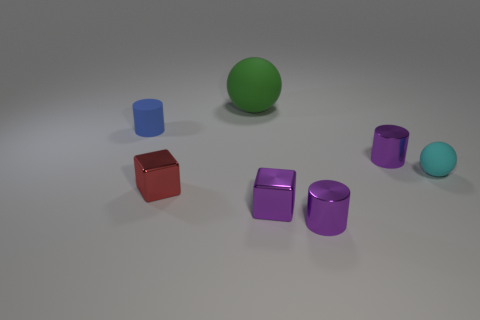How many purple matte balls have the same size as the blue matte object?
Ensure brevity in your answer.  0. Are there any tiny purple things of the same shape as the cyan thing?
Provide a short and direct response. No. There is another matte thing that is the same size as the blue rubber thing; what color is it?
Offer a terse response. Cyan. The matte sphere in front of the rubber object left of the large matte object is what color?
Keep it short and to the point. Cyan. There is a matte thing that is to the left of the green thing; is its color the same as the big matte ball?
Your response must be concise. No. There is a tiny cyan thing right of the rubber ball behind the tiny metallic object that is behind the cyan matte sphere; what shape is it?
Your answer should be very brief. Sphere. What number of small purple cylinders are behind the matte sphere in front of the tiny blue thing?
Your answer should be very brief. 1. Are the tiny cyan sphere and the large green thing made of the same material?
Your response must be concise. Yes. There is a matte object in front of the tiny blue thing behind the red thing; how many small purple shiny cubes are in front of it?
Your answer should be very brief. 1. What is the color of the rubber object behind the small rubber cylinder?
Your answer should be compact. Green. 